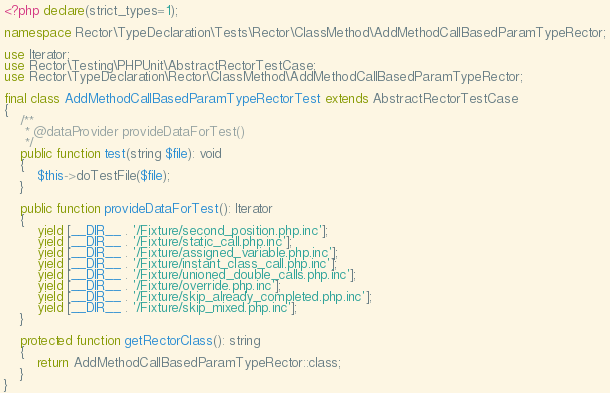Convert code to text. <code><loc_0><loc_0><loc_500><loc_500><_PHP_><?php declare(strict_types=1);

namespace Rector\TypeDeclaration\Tests\Rector\ClassMethod\AddMethodCallBasedParamTypeRector;

use Iterator;
use Rector\Testing\PHPUnit\AbstractRectorTestCase;
use Rector\TypeDeclaration\Rector\ClassMethod\AddMethodCallBasedParamTypeRector;

final class AddMethodCallBasedParamTypeRectorTest extends AbstractRectorTestCase
{
    /**
     * @dataProvider provideDataForTest()
     */
    public function test(string $file): void
    {
        $this->doTestFile($file);
    }

    public function provideDataForTest(): Iterator
    {
        yield [__DIR__ . '/Fixture/second_position.php.inc'];
        yield [__DIR__ . '/Fixture/static_call.php.inc'];
        yield [__DIR__ . '/Fixture/assigned_variable.php.inc'];
        yield [__DIR__ . '/Fixture/instant_class_call.php.inc'];
        yield [__DIR__ . '/Fixture/unioned_double_calls.php.inc'];
        yield [__DIR__ . '/Fixture/override.php.inc'];
        yield [__DIR__ . '/Fixture/skip_already_completed.php.inc'];
        yield [__DIR__ . '/Fixture/skip_mixed.php.inc'];
    }

    protected function getRectorClass(): string
    {
        return AddMethodCallBasedParamTypeRector::class;
    }
}
</code> 